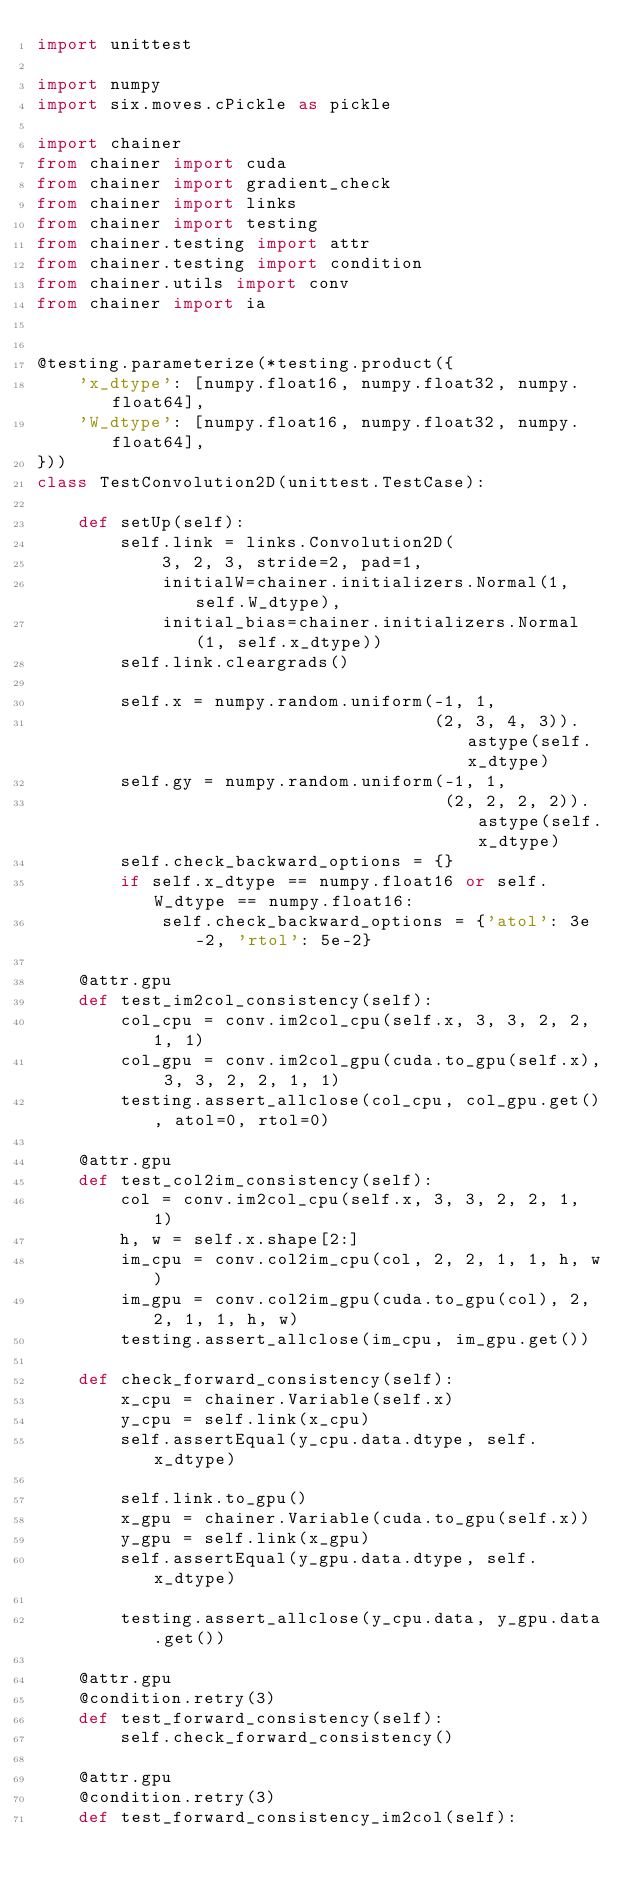<code> <loc_0><loc_0><loc_500><loc_500><_Python_>import unittest

import numpy
import six.moves.cPickle as pickle

import chainer
from chainer import cuda
from chainer import gradient_check
from chainer import links
from chainer import testing
from chainer.testing import attr
from chainer.testing import condition
from chainer.utils import conv
from chainer import ia


@testing.parameterize(*testing.product({
    'x_dtype': [numpy.float16, numpy.float32, numpy.float64],
    'W_dtype': [numpy.float16, numpy.float32, numpy.float64],
}))
class TestConvolution2D(unittest.TestCase):

    def setUp(self):
        self.link = links.Convolution2D(
            3, 2, 3, stride=2, pad=1,
            initialW=chainer.initializers.Normal(1, self.W_dtype),
            initial_bias=chainer.initializers.Normal(1, self.x_dtype))
        self.link.cleargrads()

        self.x = numpy.random.uniform(-1, 1,
                                      (2, 3, 4, 3)).astype(self.x_dtype)
        self.gy = numpy.random.uniform(-1, 1,
                                       (2, 2, 2, 2)).astype(self.x_dtype)
        self.check_backward_options = {}
        if self.x_dtype == numpy.float16 or self.W_dtype == numpy.float16:
            self.check_backward_options = {'atol': 3e-2, 'rtol': 5e-2}

    @attr.gpu
    def test_im2col_consistency(self):
        col_cpu = conv.im2col_cpu(self.x, 3, 3, 2, 2, 1, 1)
        col_gpu = conv.im2col_gpu(cuda.to_gpu(self.x), 3, 3, 2, 2, 1, 1)
        testing.assert_allclose(col_cpu, col_gpu.get(), atol=0, rtol=0)

    @attr.gpu
    def test_col2im_consistency(self):
        col = conv.im2col_cpu(self.x, 3, 3, 2, 2, 1, 1)
        h, w = self.x.shape[2:]
        im_cpu = conv.col2im_cpu(col, 2, 2, 1, 1, h, w)
        im_gpu = conv.col2im_gpu(cuda.to_gpu(col), 2, 2, 1, 1, h, w)
        testing.assert_allclose(im_cpu, im_gpu.get())

    def check_forward_consistency(self):
        x_cpu = chainer.Variable(self.x)
        y_cpu = self.link(x_cpu)
        self.assertEqual(y_cpu.data.dtype, self.x_dtype)

        self.link.to_gpu()
        x_gpu = chainer.Variable(cuda.to_gpu(self.x))
        y_gpu = self.link(x_gpu)
        self.assertEqual(y_gpu.data.dtype, self.x_dtype)

        testing.assert_allclose(y_cpu.data, y_gpu.data.get())

    @attr.gpu
    @condition.retry(3)
    def test_forward_consistency(self):
        self.check_forward_consistency()

    @attr.gpu
    @condition.retry(3)
    def test_forward_consistency_im2col(self):</code> 